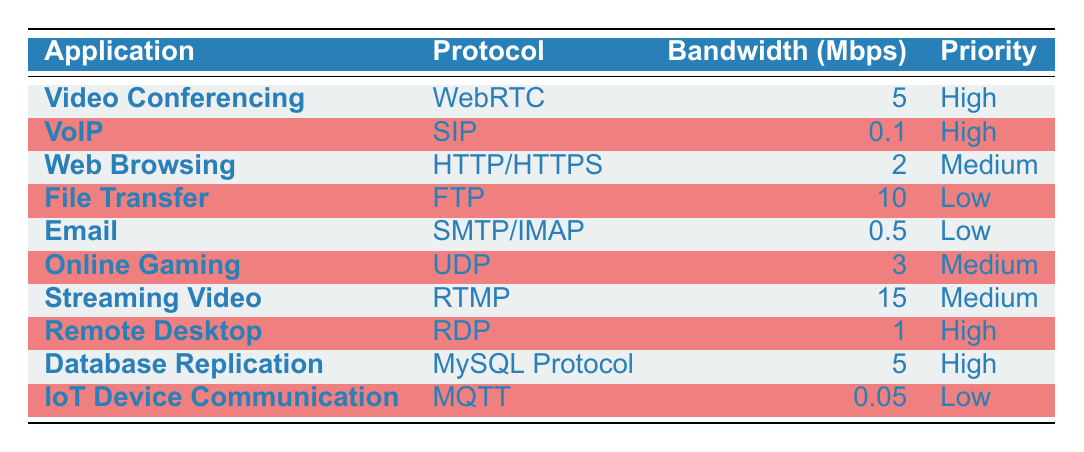What is the recommended bandwidth for Video Conferencing? The table lists "Video Conferencing" under the first row, showing its recommended bandwidth is 5 Mbps.
Answer: 5 Mbps Which application has the lowest bandwidth requirement? The application with the lowest bandwidth requirement is "IoT Device Communication," which has a recommended bandwidth of 0.05 Mbps, as shown in the last row of the table.
Answer: IoT Device Communication What is the total recommended bandwidth for High priority applications? The high priority applications are "Video Conferencing," "VoIP," "Remote Desktop," and "Database Replication." Their recommended bandwidths are 5 + 0.1 + 1 + 5 = 11.1 Mbps.T
Answer: 11.1 Mbps Are there any applications that require more than 10 Mbps of bandwidth? By examining the table, only "Streaming Video" requires 15 Mbps, which is greater than 10 Mbps. Other applications do not exceed this requirement.
Answer: Yes How many applications have a Medium priority level? The applications categorized as Medium priority are "Web Browsing," "Online Gaming," and "Streaming Video," totaling 3 applications based on the table.
Answer: 3 applications What is the difference in recommended bandwidth between File Transfer and Streaming Video? "File Transfer" has a recommended bandwidth of 10 Mbps and "Streaming Video" has 15 Mbps. The difference is calculated as 15 - 10 = 5 Mbps.
Answer: 5 Mbps Is it true that all applications listed use a protocol? Each application in the table is paired with a specific protocol; thus, it is true that all applications listed use a protocol.
Answer: Yes Which application has the highest recommended bandwidth, and what is it? The application with the highest recommended bandwidth is "Streaming Video," which has a bandwidth of 15 Mbps, as identified in the table.
Answer: Streaming Video, 15 Mbps What is the average recommended bandwidth across all applications? To find the average, sum all the recommended bandwidths: 5 + 0.1 + 2 + 10 + 0.5 + 3 + 15 + 1 + 5 + 0.05 = 37.65 Mbps. There are 10 applications, so the average is 37.65/10 = 3.765 Mbps.
Answer: 3.765 Mbps 